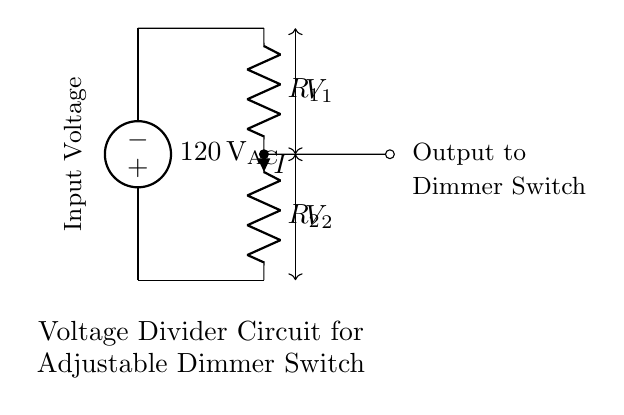What is the input voltage of this circuit? The input voltage is specified as 120 Volts. This can be directly observed from the voltage source label in the diagram as it shows "120 V AC".
Answer: 120 Volts What are the components of this voltage divider circuit? The components present in the circuit are a voltage source and two resistors (R1 and R2). The circuit diagram specifically labels the voltage source and each resistor that forms the voltage divider.
Answer: Voltage source, R1, R2 What is the current direction in the circuit? The current direction is indicated by the arrow on the resistor R2, which shows the current flowing downwards through R2 and towards ground.
Answer: Downward What is the output voltage taken from this circuit? The output voltage can be referenced as V2, which represents the voltage across resistor R2, where the output is taken before the ground. This is often used in voltage divider configurations.
Answer: V2 How is the intensity of the lighting adjusted in this circuit? The intensity is adjusted by changing the resistance values of R1 and R2 or by varying R2’s resistance if it's a variable resistor, which alters the voltage V2 output to the dimmer switch, thus controlling the lighting intensity.
Answer: By varying R2 What is the relationship between R1 and R2 for voltage division? The relationship is expressed as V2 = (R2 / (R1 + R2)) * Vin, where Vin is the input voltage. This formula shows how the output voltage V2 depends on the ratio of the resistances R1 and R2 in the voltage divider.
Answer: V2 = (R2 / (R1 + R2)) * Vin What happens to the output voltage when R2 is increased? Increasing R2 will result in a higher output voltage V2 (assuming R1 remains constant) because a larger R2 increases the proportion of the total voltage drop across it, thereby raising the output.
Answer: V2 increases 